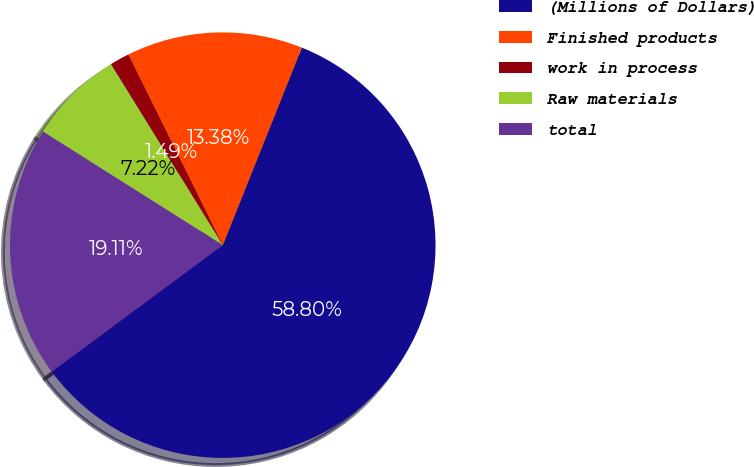<chart> <loc_0><loc_0><loc_500><loc_500><pie_chart><fcel>(Millions of Dollars)<fcel>Finished products<fcel>work in process<fcel>Raw materials<fcel>total<nl><fcel>58.79%<fcel>13.38%<fcel>1.49%<fcel>7.22%<fcel>19.11%<nl></chart> 